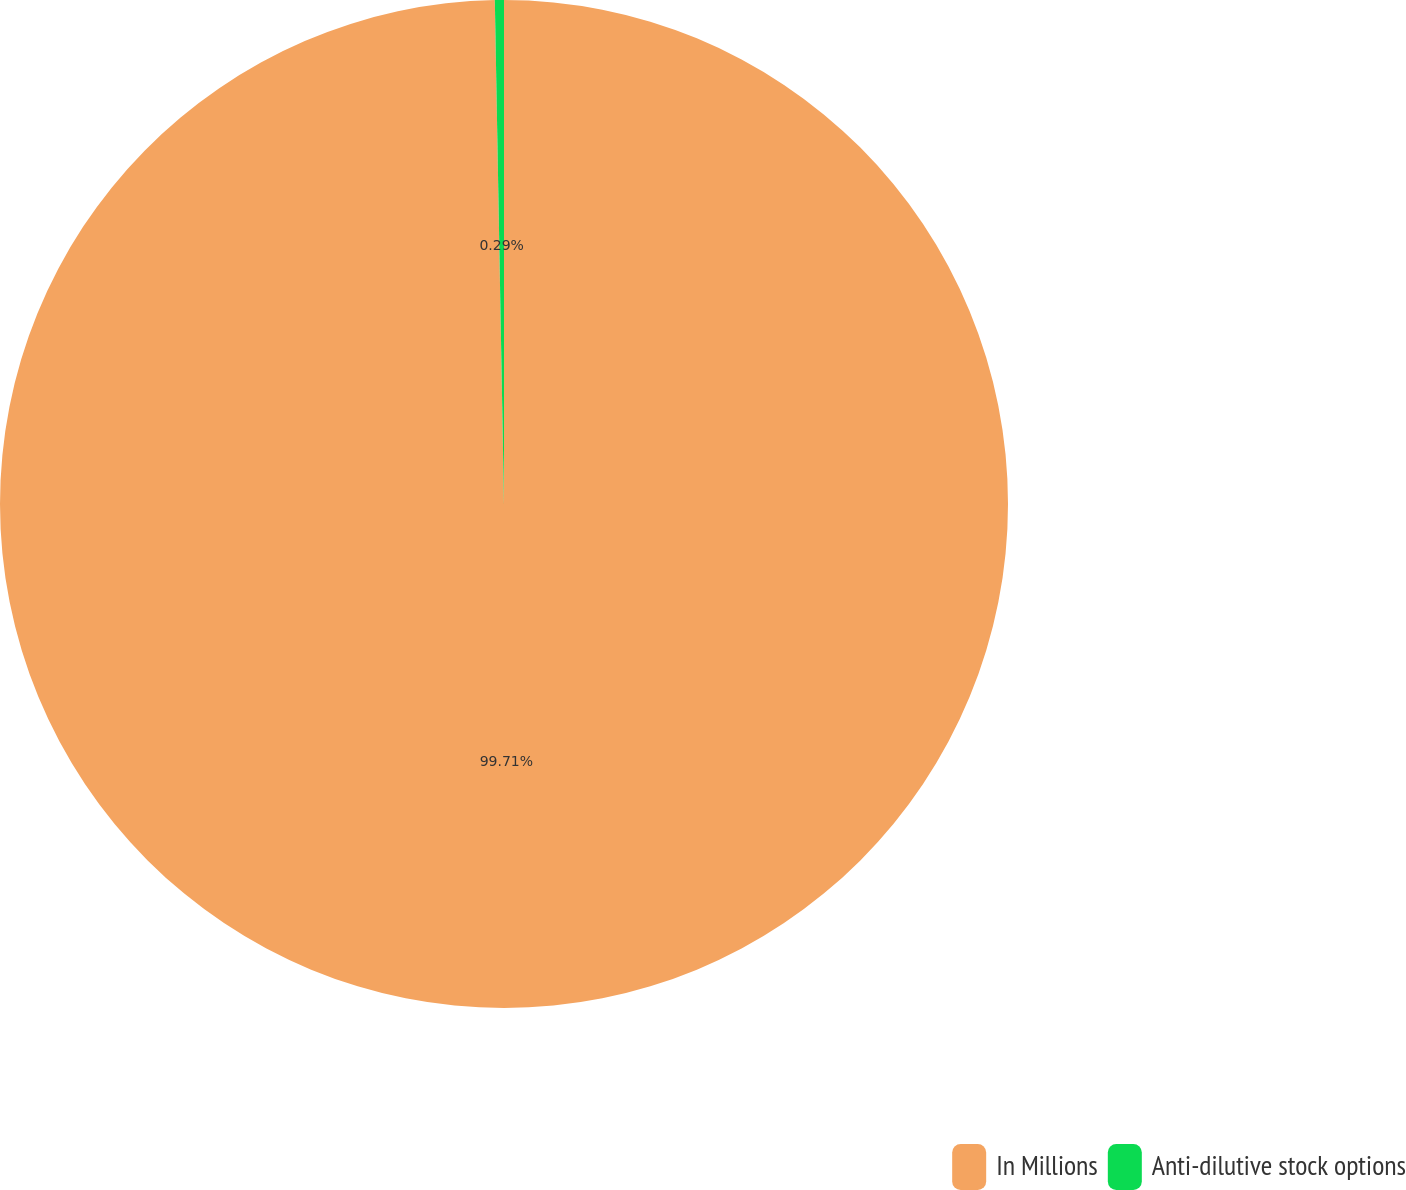Convert chart to OTSL. <chart><loc_0><loc_0><loc_500><loc_500><pie_chart><fcel>In Millions<fcel>Anti-dilutive stock options<nl><fcel>99.71%<fcel>0.29%<nl></chart> 